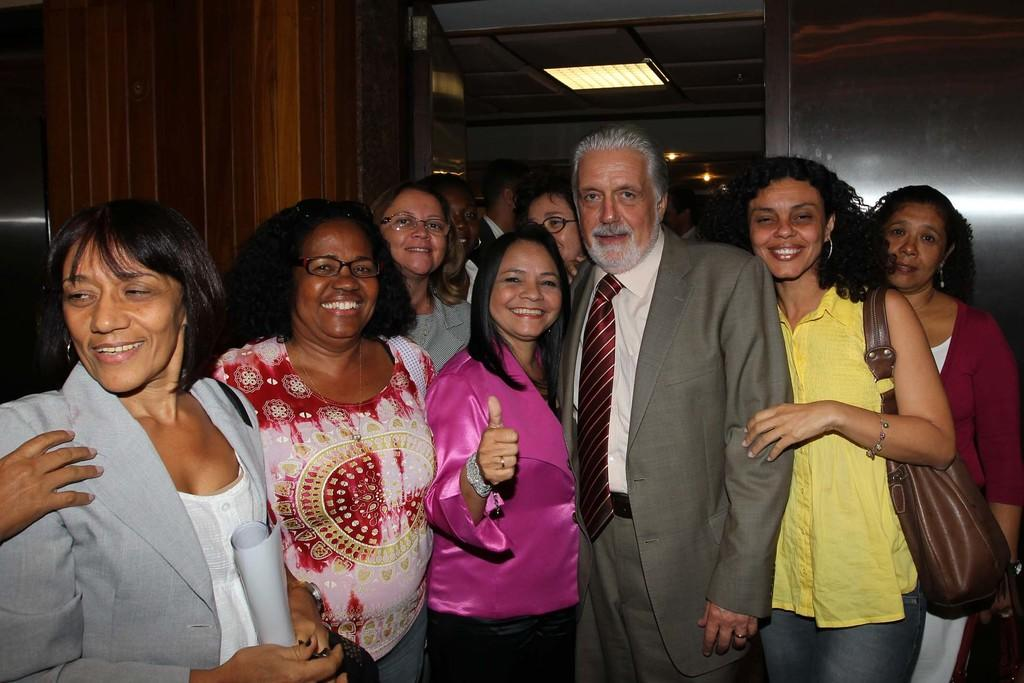How many people are in the image? There is a group of people standing in the image, but the exact number cannot be determined from the provided facts. What is the woman holding in the image? The woman is holding some papers in the image. What type of structure is visible in the image? There is a wall and a roof visible in the image, suggesting a building or enclosed space. What type of lighting is present in the image? There are ceiling lights present in the image. What type of soup is being served in the image? There is no soup present in the image. How many oranges are visible on the table in the image? There is no mention of oranges in the provided facts, so it cannot be determined if any are present in the image. 